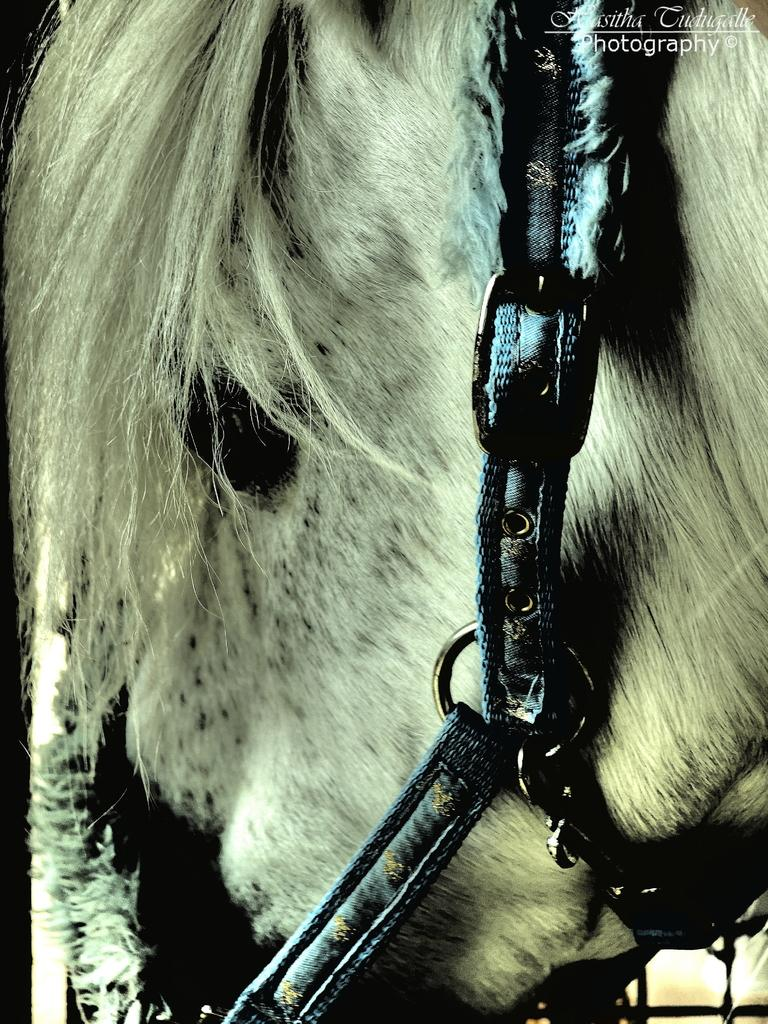What animal is present in the image? There is a horse in the image. How is the horse being restrained in the image? The horse is tied with belts. What type of lumber is being used to feed the horse in the image? There is no lumber present in the image, and the horse is not being fed in the image. 